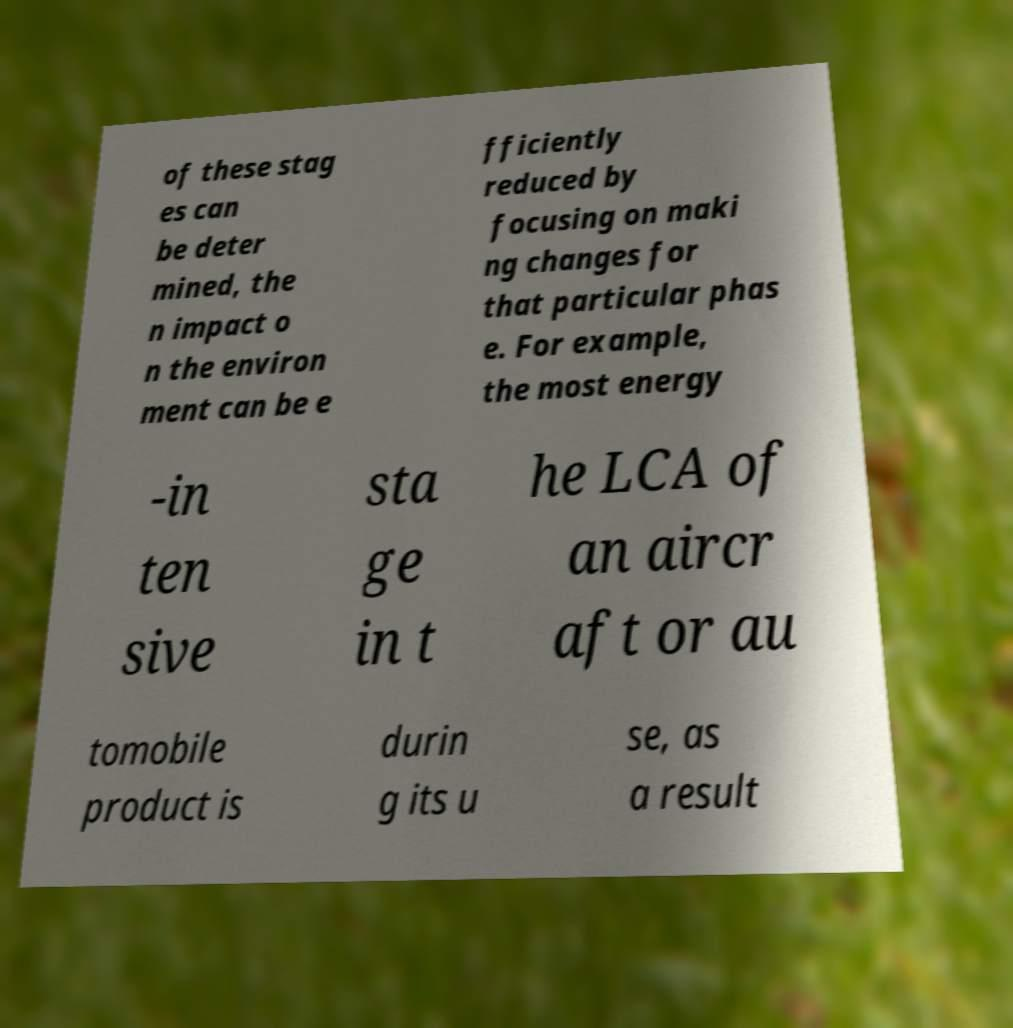Can you accurately transcribe the text from the provided image for me? of these stag es can be deter mined, the n impact o n the environ ment can be e fficiently reduced by focusing on maki ng changes for that particular phas e. For example, the most energy -in ten sive sta ge in t he LCA of an aircr aft or au tomobile product is durin g its u se, as a result 